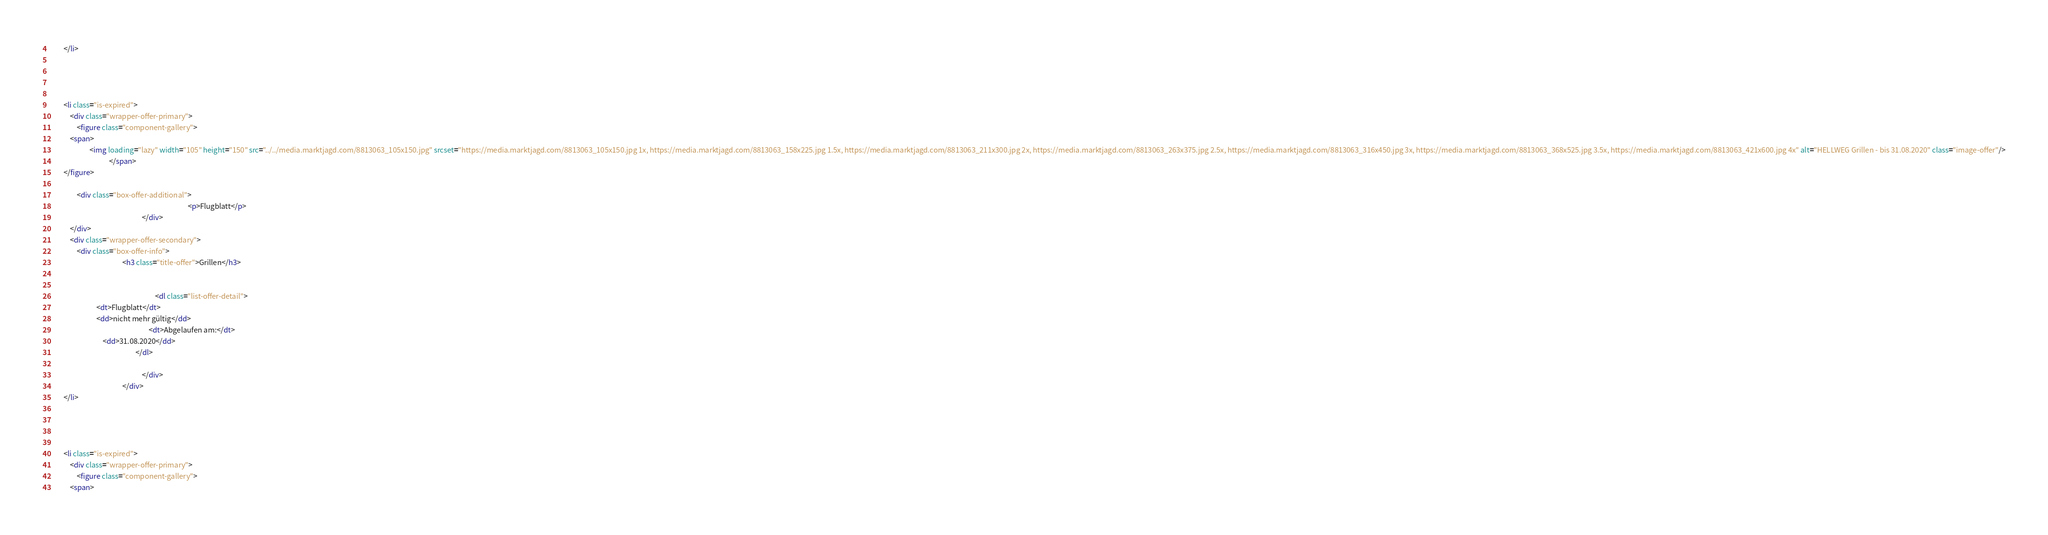Convert code to text. <code><loc_0><loc_0><loc_500><loc_500><_HTML_>        </li>
                                                                            
        
                                        
                                                                            
        <li class="is-expired">
            <div class="wrapper-offer-primary">
                <figure class="component-gallery">
            <span>
                        <img loading="lazy" width="105" height="150" src="../../media.marktjagd.com/8813063_105x150.jpg" srcset="https://media.marktjagd.com/8813063_105x150.jpg 1x, https://media.marktjagd.com/8813063_158x225.jpg 1.5x, https://media.marktjagd.com/8813063_211x300.jpg 2x, https://media.marktjagd.com/8813063_263x375.jpg 2.5x, https://media.marktjagd.com/8813063_316x450.jpg 3x, https://media.marktjagd.com/8813063_368x525.jpg 3.5x, https://media.marktjagd.com/8813063_421x600.jpg 4x" alt="HELLWEG Grillen - bis 31.08.2020" class="image-offer"/>
                                    </span>
        </figure>

                <div class="box-offer-additional">
                                                                                    <p>Flugblatt</p>
                                                        </div>
            </div>
            <div class="wrapper-offer-secondary">
                <div class="box-offer-info">
                                            <h3 class="title-offer">Grillen</h3>
                    
                                        
                                                                <dl class="list-offer-detail">
                            <dt>Flugblatt</dt>
                            <dd>nicht mehr gültig</dd>
                                                            <dt>Abgelaufen am:</dt>
                                <dd>31.08.2020</dd>
                                                    </dl>
                    
                                                        </div>
                                            </div>
        </li>
                                                                            
        
                                        
                                                                            
        <li class="is-expired">
            <div class="wrapper-offer-primary">
                <figure class="component-gallery">
            <span></code> 